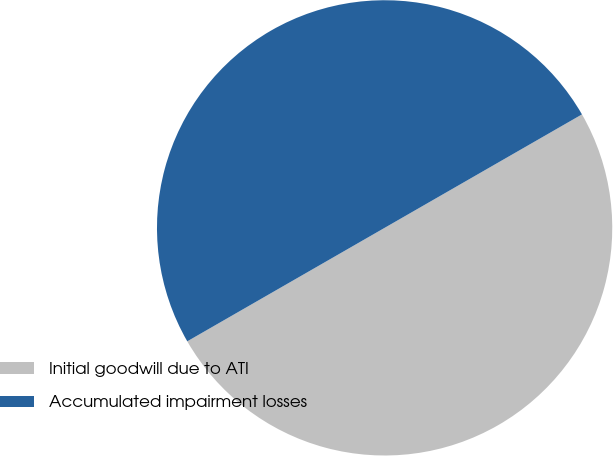Convert chart to OTSL. <chart><loc_0><loc_0><loc_500><loc_500><pie_chart><fcel>Initial goodwill due to ATI<fcel>Accumulated impairment losses<nl><fcel>50.0%<fcel>50.0%<nl></chart> 